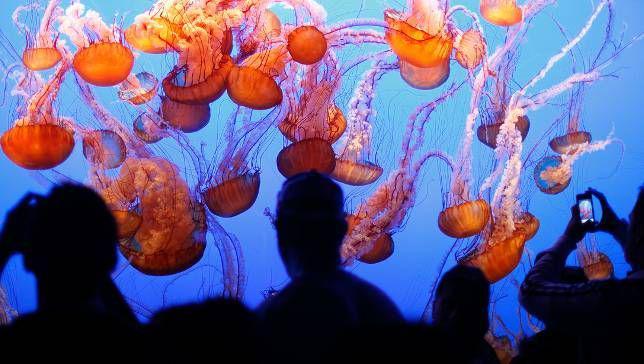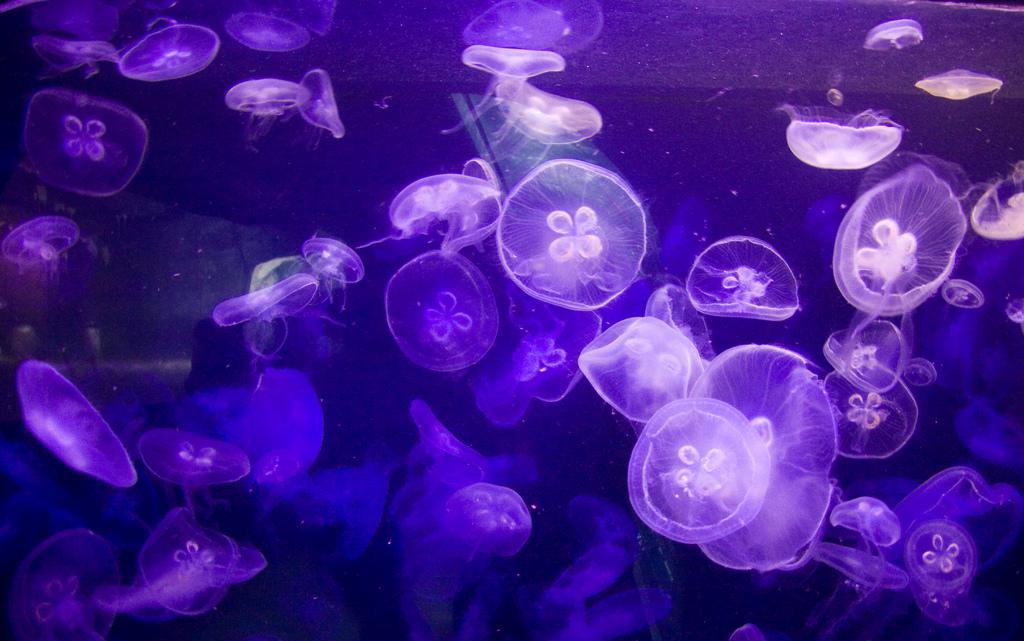The first image is the image on the left, the second image is the image on the right. Examine the images to the left and right. Is the description "Gold colored jellyfish are swimming down." accurate? Answer yes or no. Yes. The first image is the image on the left, the second image is the image on the right. For the images shown, is this caption "An image shows at least a dozen vivid orange jellyfish, with tendrils trailing upward." true? Answer yes or no. Yes. 